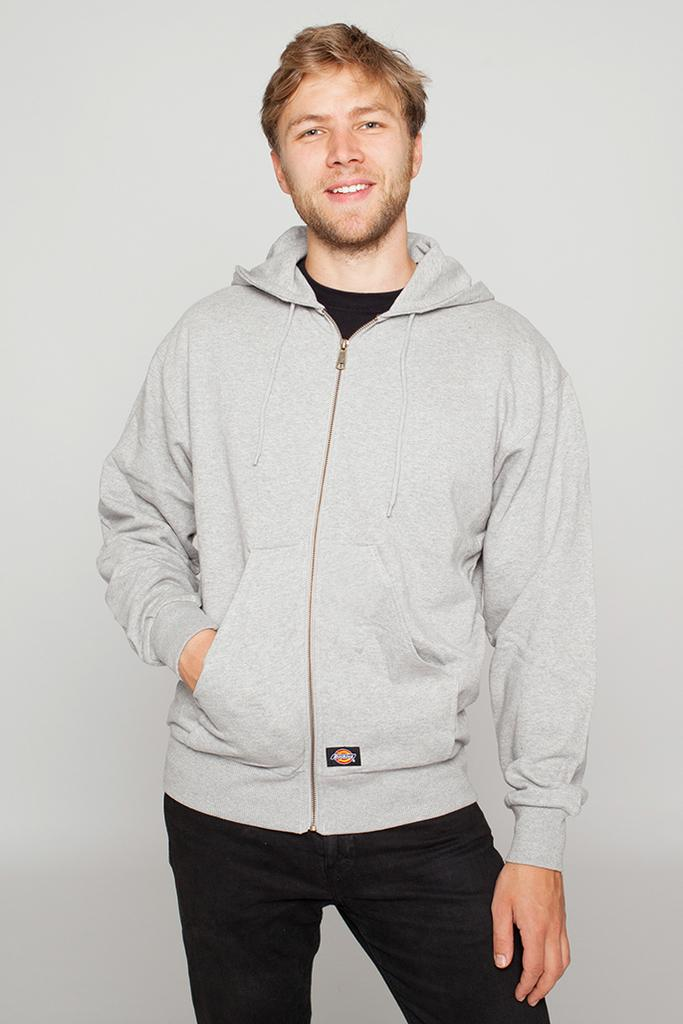Who is the main subject in the image? There is a man in the center of the image. What is the man doing in the image? The man is standing and smiling. What can be seen in the background of the image? There is a wall in the background of the image. What type of fruit is the man holding in the image? There is no fruit present in the image; the man is simply standing and smiling. 